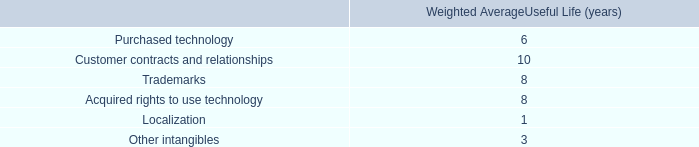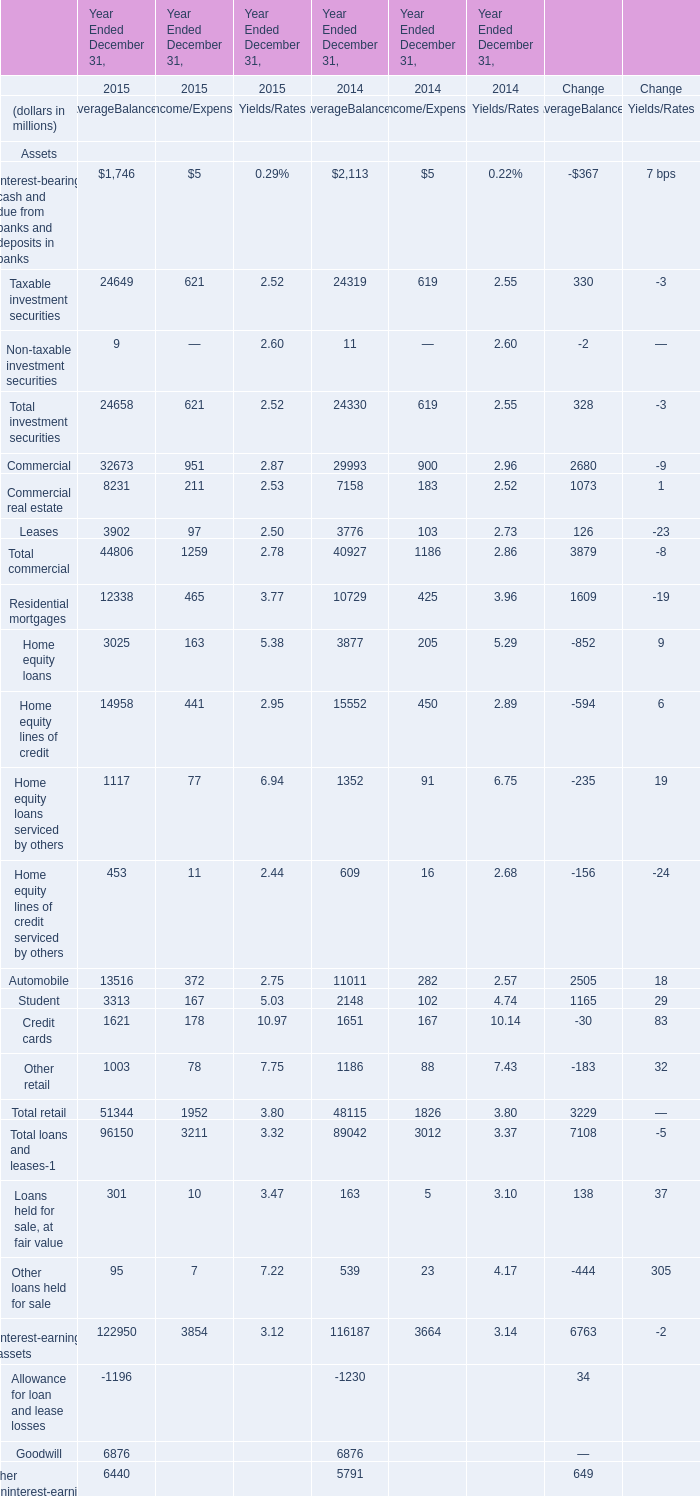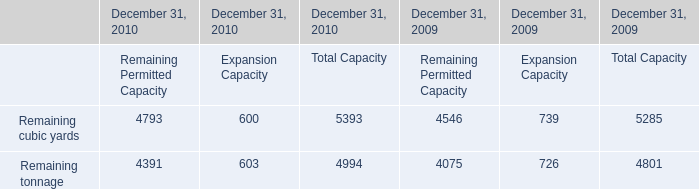In the year with largest amount of Taxable investment securities , what's the sum of Total investment securities and Commercial for Average Balances ? (in million) 
Computations: (24658 + 32673)
Answer: 57331.0. 